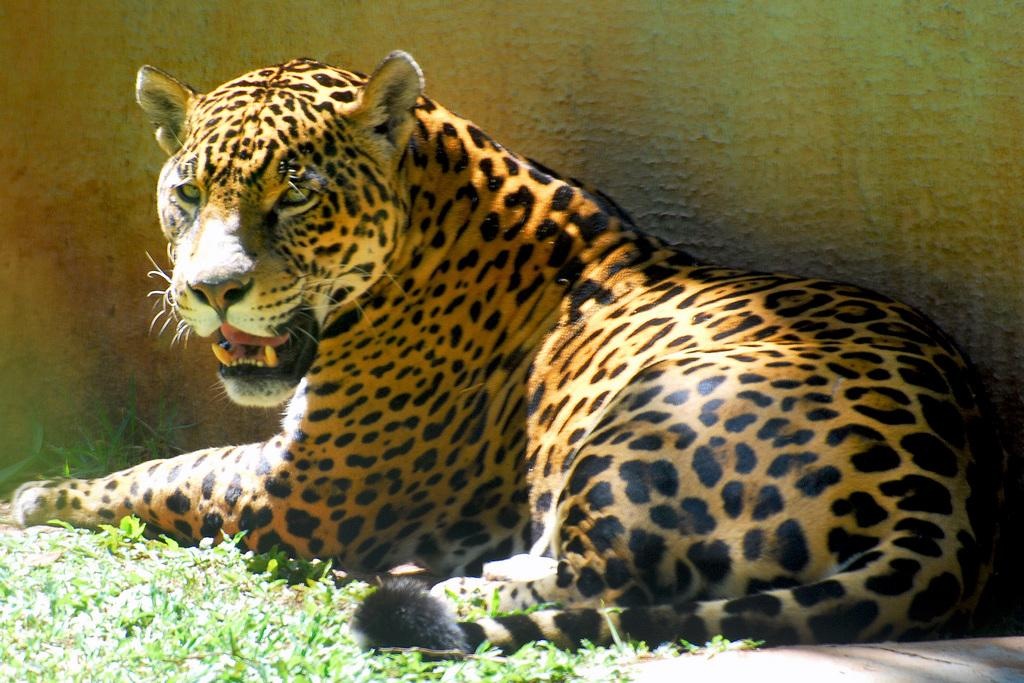What animal can be seen in the picture? There is a tiger in the picture. What type of terrain is visible on the ground in the picture? There is grass on the ground in the picture. What can be seen in the background of the picture? There is a wall in the background of the picture. What type of things can be seen at the seashore in the image? There is no seashore present in the image; it features a tiger in a grassy area with a wall in the background. 